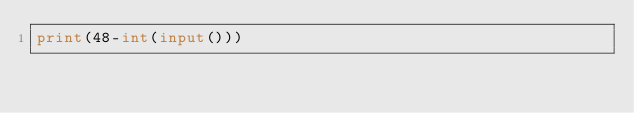Convert code to text. <code><loc_0><loc_0><loc_500><loc_500><_Python_>print(48-int(input()))</code> 